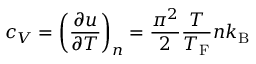<formula> <loc_0><loc_0><loc_500><loc_500>c _ { V } = \left ( { \frac { \partial u } { \partial T } } \right ) _ { n } = { \frac { \pi ^ { 2 } } { 2 } } { \frac { T } { T _ { F } } } n k _ { B }</formula> 